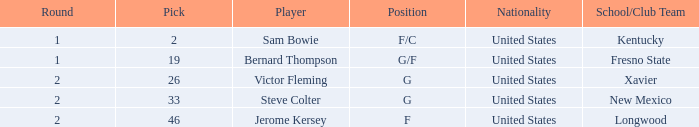When the position is "g" and the pick is above 26, what is the nationality? United States. 